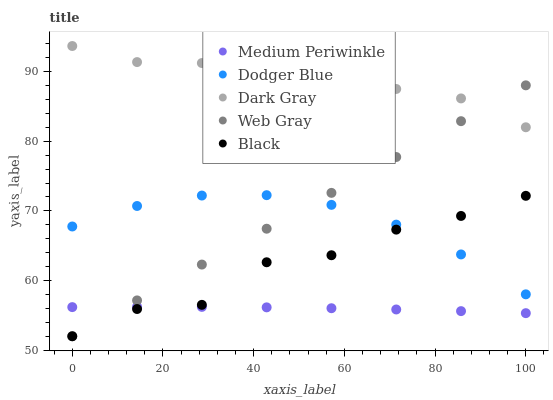Does Medium Periwinkle have the minimum area under the curve?
Answer yes or no. Yes. Does Dark Gray have the maximum area under the curve?
Answer yes or no. Yes. Does Dodger Blue have the minimum area under the curve?
Answer yes or no. No. Does Dodger Blue have the maximum area under the curve?
Answer yes or no. No. Is Web Gray the smoothest?
Answer yes or no. Yes. Is Black the roughest?
Answer yes or no. Yes. Is Dodger Blue the smoothest?
Answer yes or no. No. Is Dodger Blue the roughest?
Answer yes or no. No. Does Web Gray have the lowest value?
Answer yes or no. Yes. Does Dodger Blue have the lowest value?
Answer yes or no. No. Does Dark Gray have the highest value?
Answer yes or no. Yes. Does Dodger Blue have the highest value?
Answer yes or no. No. Is Medium Periwinkle less than Dark Gray?
Answer yes or no. Yes. Is Dark Gray greater than Medium Periwinkle?
Answer yes or no. Yes. Does Dodger Blue intersect Black?
Answer yes or no. Yes. Is Dodger Blue less than Black?
Answer yes or no. No. Is Dodger Blue greater than Black?
Answer yes or no. No. Does Medium Periwinkle intersect Dark Gray?
Answer yes or no. No. 